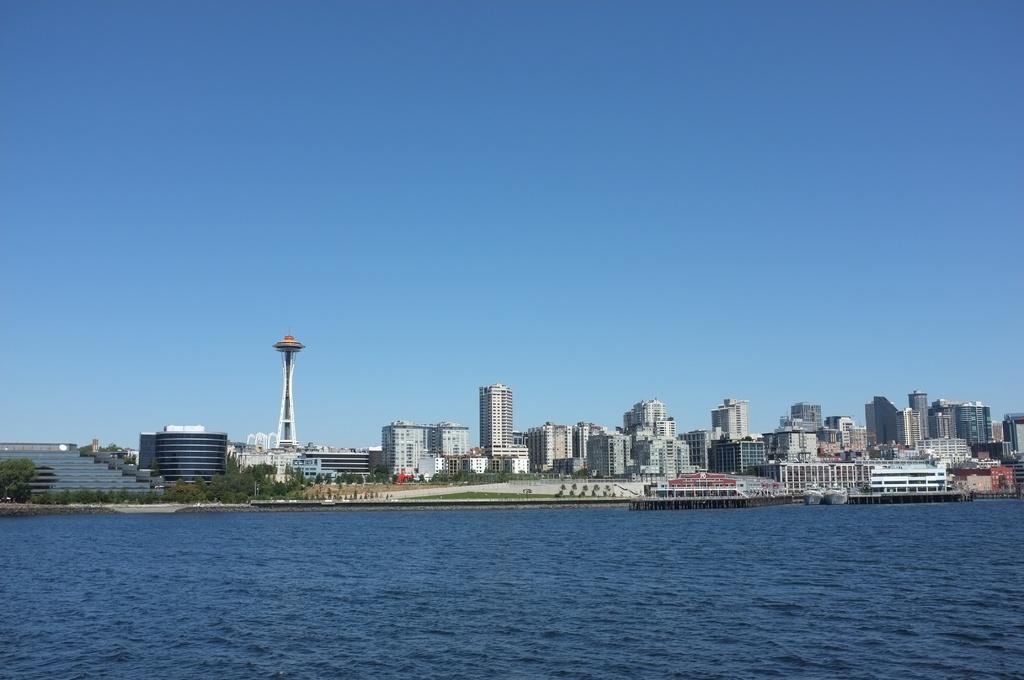Describe this image in one or two sentences. In the image we can see there are many buildings and a tower. We can even see there are trees, stairs, grass, water and the sky. 